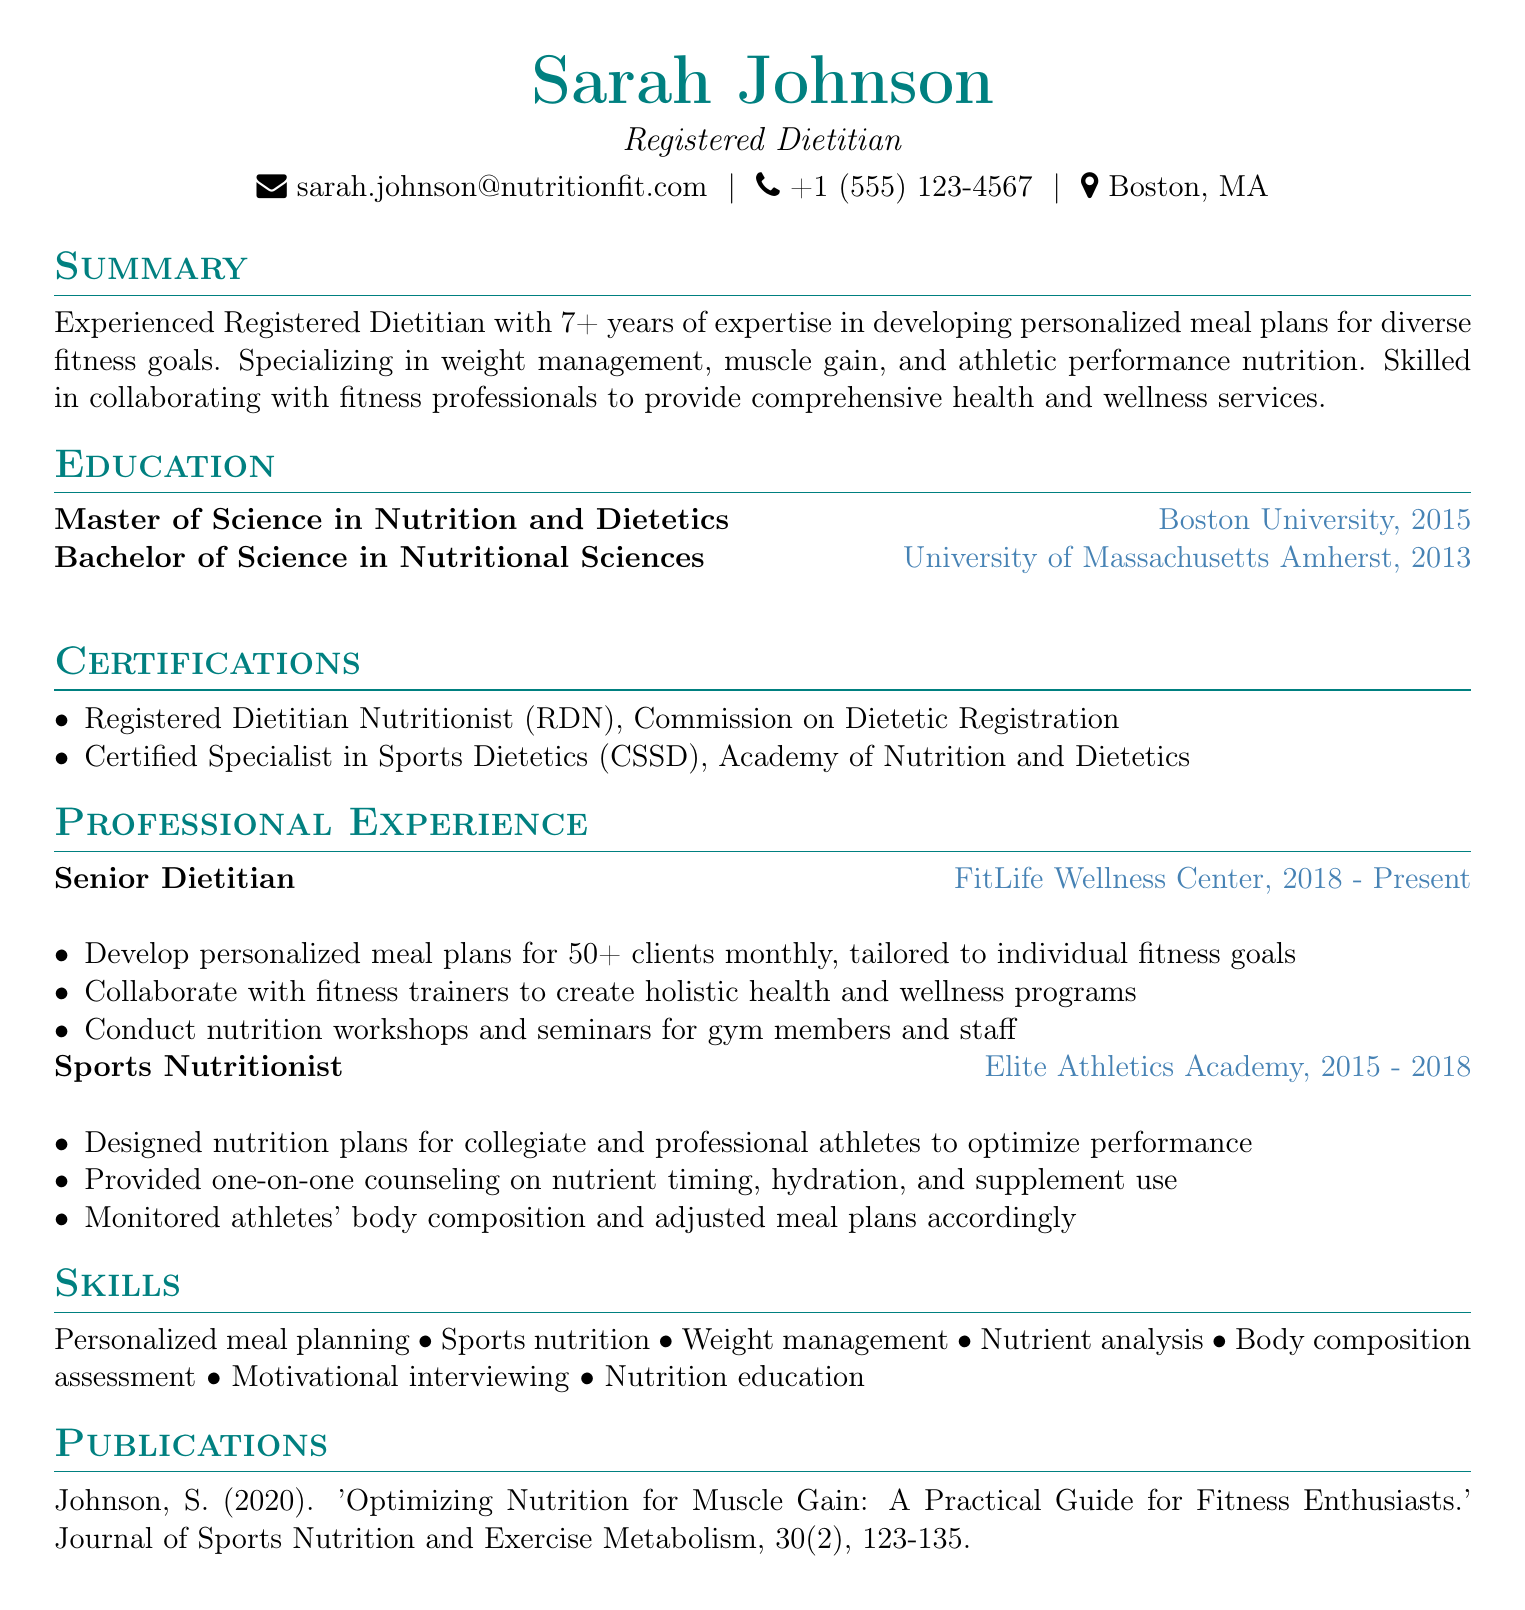What is Sarah Johnson's title? The title is provided in the personal information section of the document, which states her professional designation.
Answer: Registered Dietitian How many years of experience does Sarah have? The summary section specifically mentions the number of years of expertise Sarah possesses in her field.
Answer: 7+ Which institution did Sarah attend for her Master's degree? The education section lists the institutions along with the degrees earned, highlighting her Master’s degree institution.
Answer: Boston University What certification does Sarah have related to sports dietetics? The certifications section notes specific certifications Sarah holds, especially in sports dietetics.
Answer: Certified Specialist in Sports Dietetics (CSSD) How many clients does Sarah develop meal plans for monthly at FitLife Wellness Center? The professional experience at FitLife Wellness Center states the approximate number of clients for whom she develops meal plans each month.
Answer: 50+ What role did Sarah hold from 2015 to 2018? The professional experience section clearly outlines Sarah's job title during her time at Elite Athletics Academy.
Answer: Sports Nutritionist Which publication did Sarah write? The publications section features a title of a specific article written by Sarah, detailing her contribution to the subject of sports nutrition.
Answer: 'Optimizing Nutrition for Muscle Gain: A Practical Guide for Fitness Enthusiasts.' What is one skill listed in Sarah's CV? The skills section provides a list of competencies, one of which can be easily identified as part of her expertise.
Answer: Sports nutrition Where is Sarah located? The personal information section includes contact details, including her location.
Answer: Boston, MA 